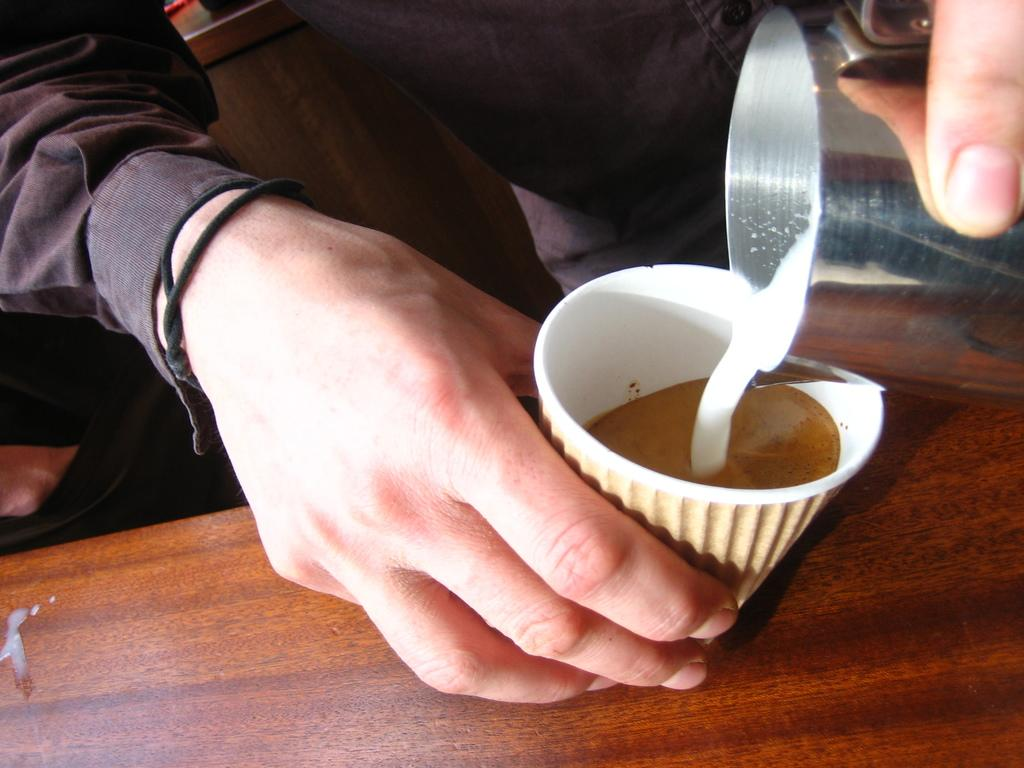What object can be seen on the table in the image? There is a cup on the table in the image. Where is the table located in the image? The table is in the bottom right side of the image. What is the person in the image holding? The person is holding a glass. Where is the person standing in the image? The person is standing in the top right side of the image. What type of quartz can be seen in the person's hand in the image? There is no quartz present in the image; the person is holding a glass. How many beads are visible on the table in the image? There are no beads visible on the table in the image; there is only a cup present. 